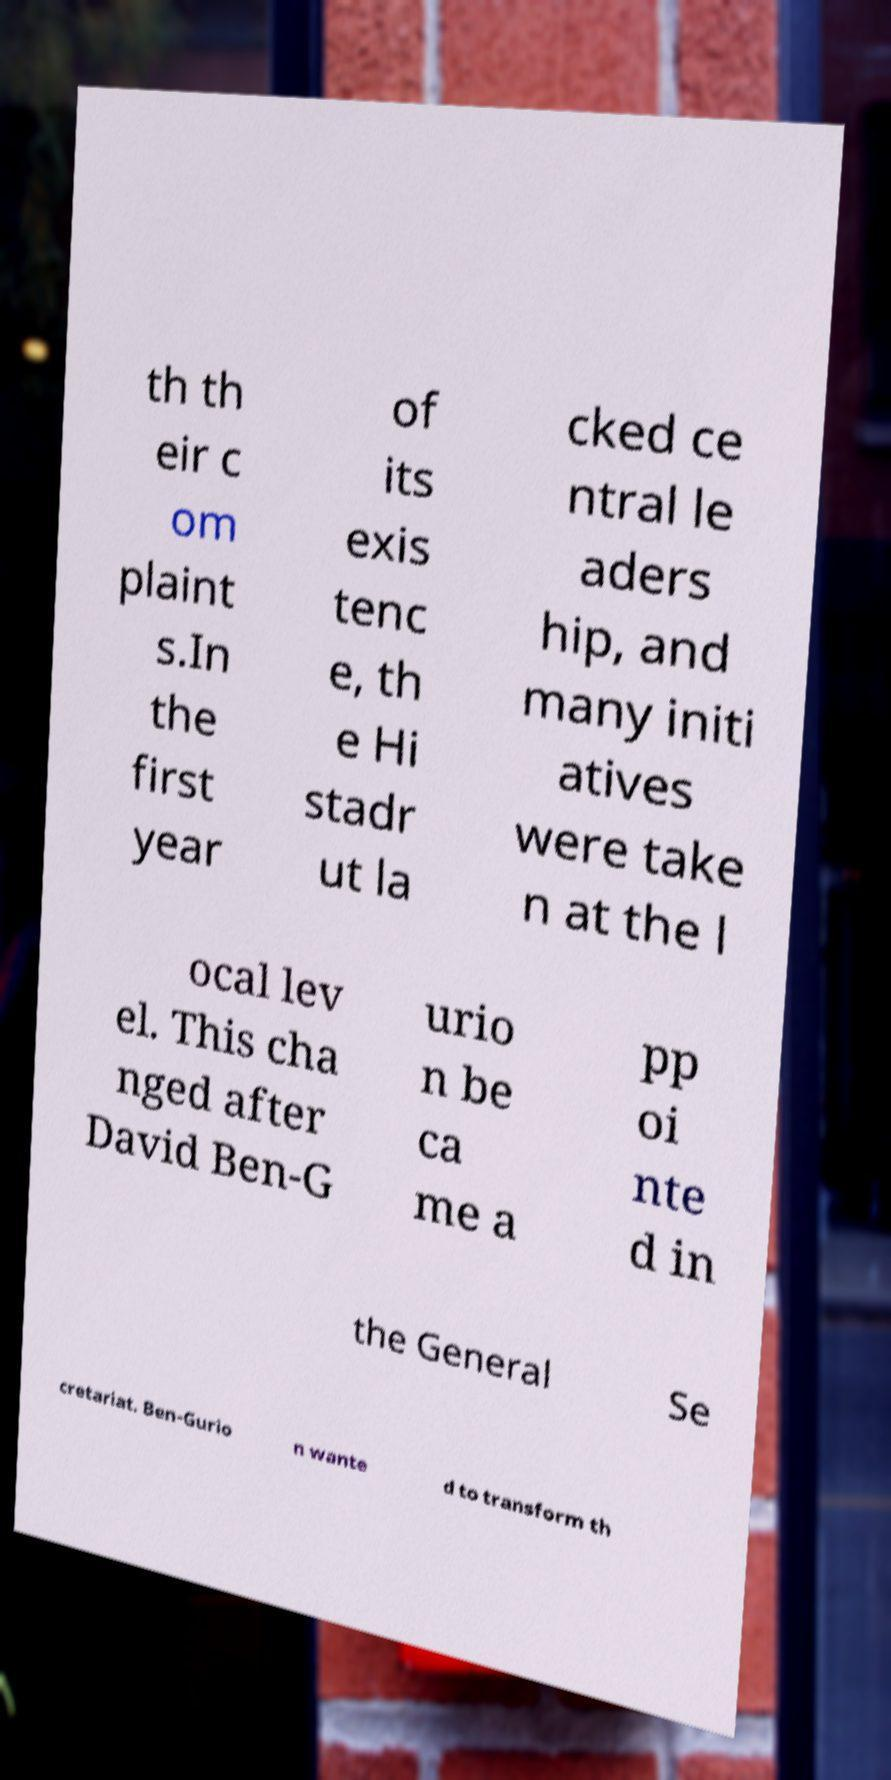There's text embedded in this image that I need extracted. Can you transcribe it verbatim? th th eir c om plaint s.In the first year of its exis tenc e, th e Hi stadr ut la cked ce ntral le aders hip, and many initi atives were take n at the l ocal lev el. This cha nged after David Ben-G urio n be ca me a pp oi nte d in the General Se cretariat. Ben-Gurio n wante d to transform th 